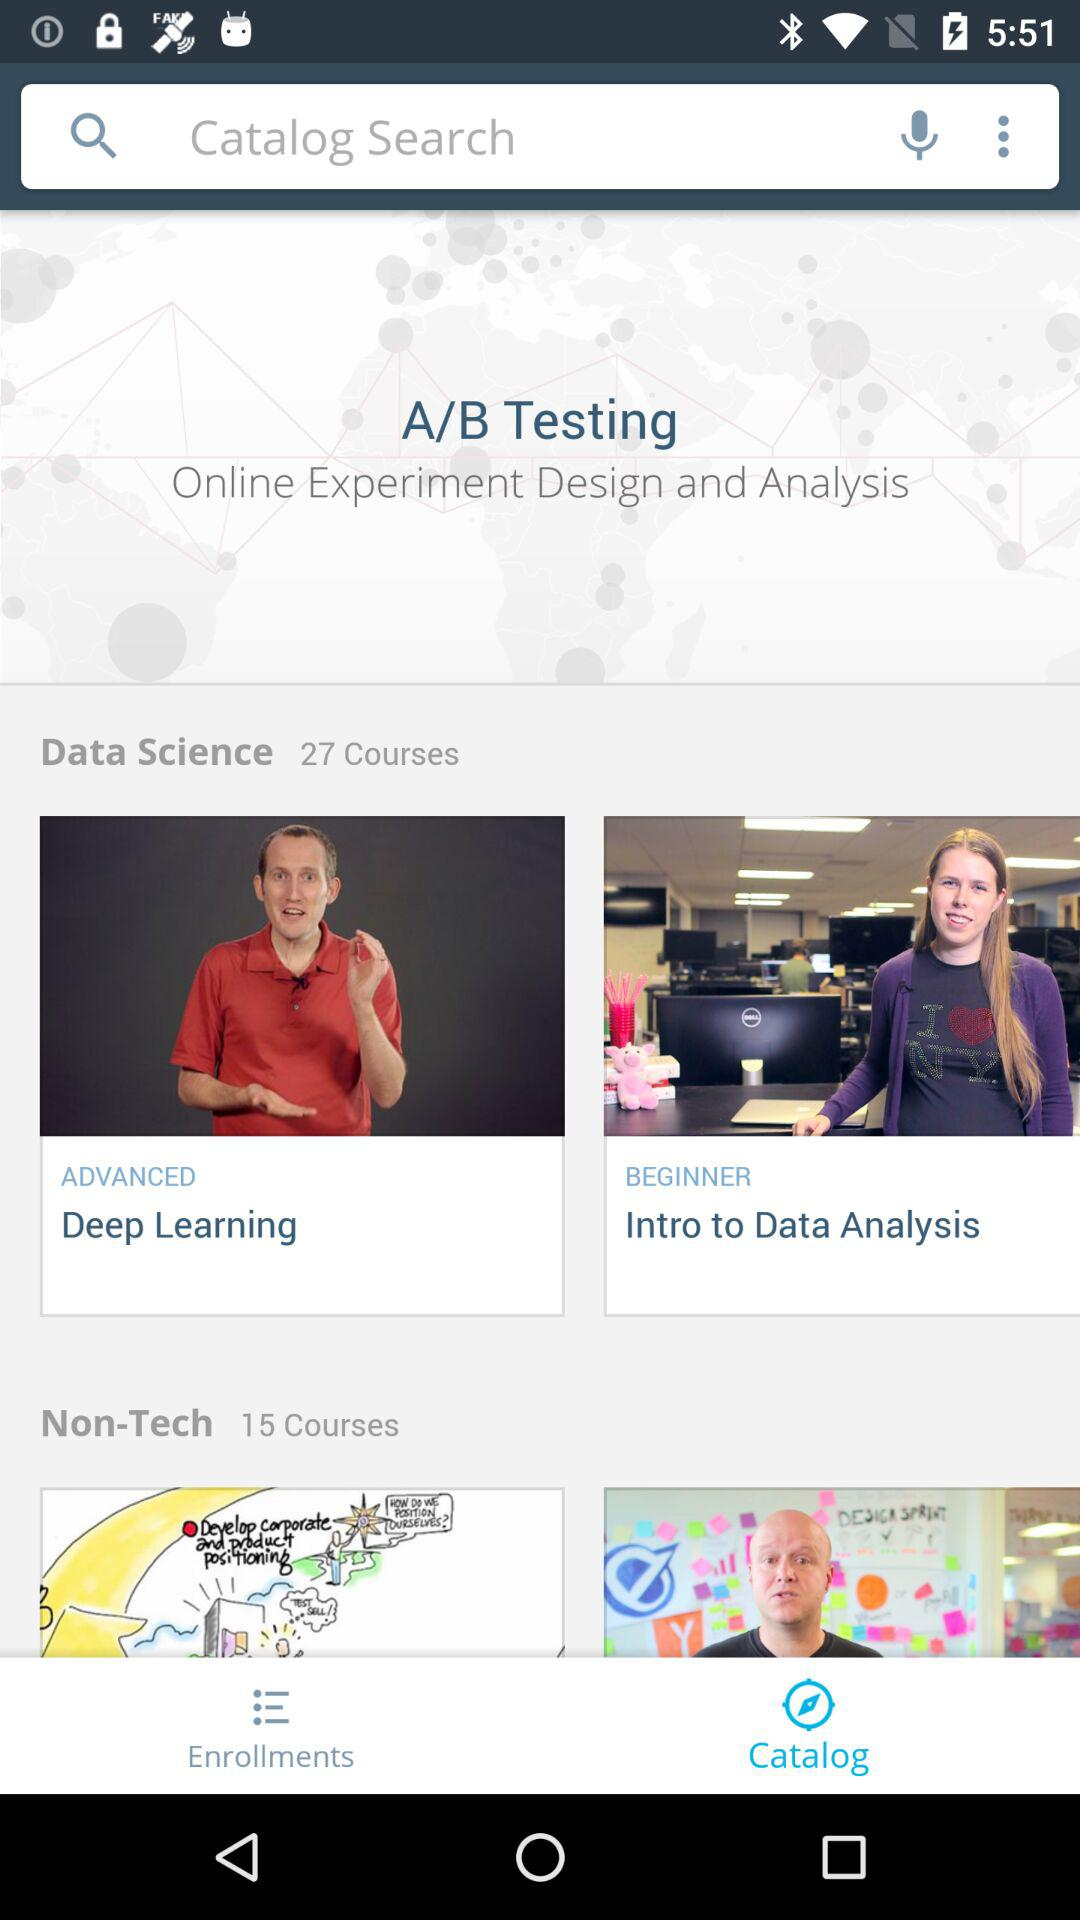How many courses in total are there in "Non-Tech"? There are 15 courses in total. 